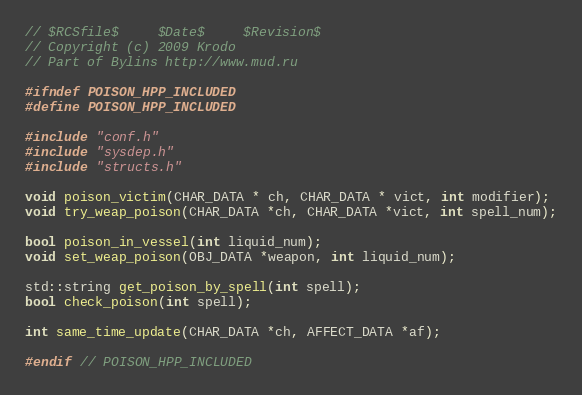<code> <loc_0><loc_0><loc_500><loc_500><_C++_>// $RCSfile$     $Date$     $Revision$
// Copyright (c) 2009 Krodo
// Part of Bylins http://www.mud.ru

#ifndef POISON_HPP_INCLUDED
#define POISON_HPP_INCLUDED

#include "conf.h"
#include "sysdep.h"
#include "structs.h"

void poison_victim(CHAR_DATA * ch, CHAR_DATA * vict, int modifier);
void try_weap_poison(CHAR_DATA *ch, CHAR_DATA *vict, int spell_num);

bool poison_in_vessel(int liquid_num);
void set_weap_poison(OBJ_DATA *weapon, int liquid_num);

std::string get_poison_by_spell(int spell);
bool check_poison(int spell);

int same_time_update(CHAR_DATA *ch, AFFECT_DATA *af);

#endif // POISON_HPP_INCLUDED
</code> 